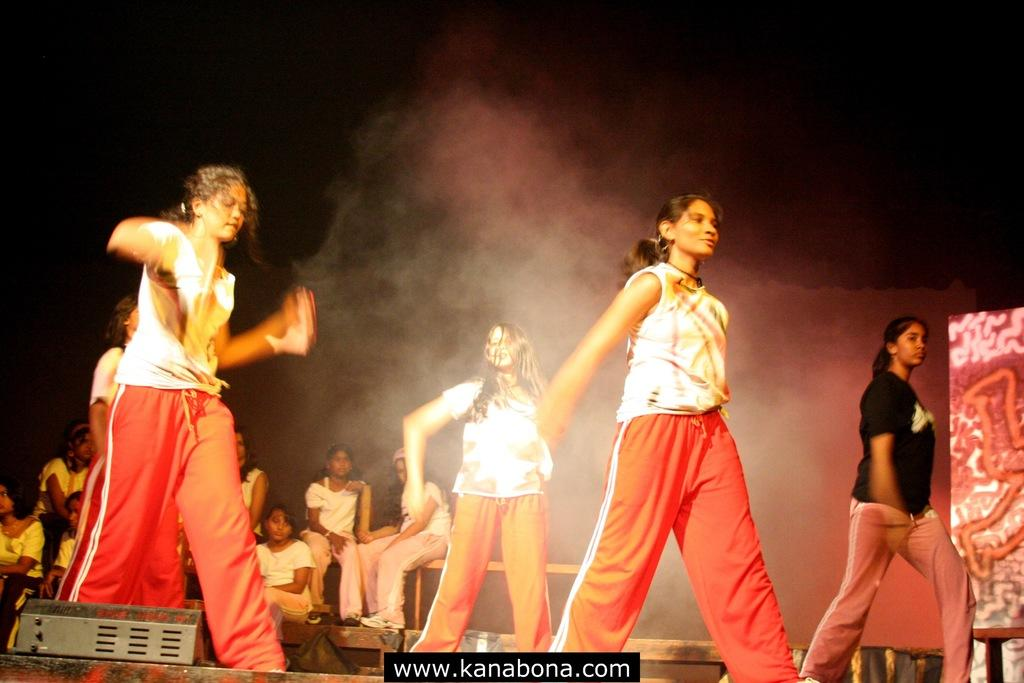What are the girls in the image doing? There are four girls dancing in the image. Can you describe the setting of the image? In the background of the image, there are people sitting. How many legs does the measure have in the image? There is no measure present in the image, so it is not possible to determine the number of legs it might have. 